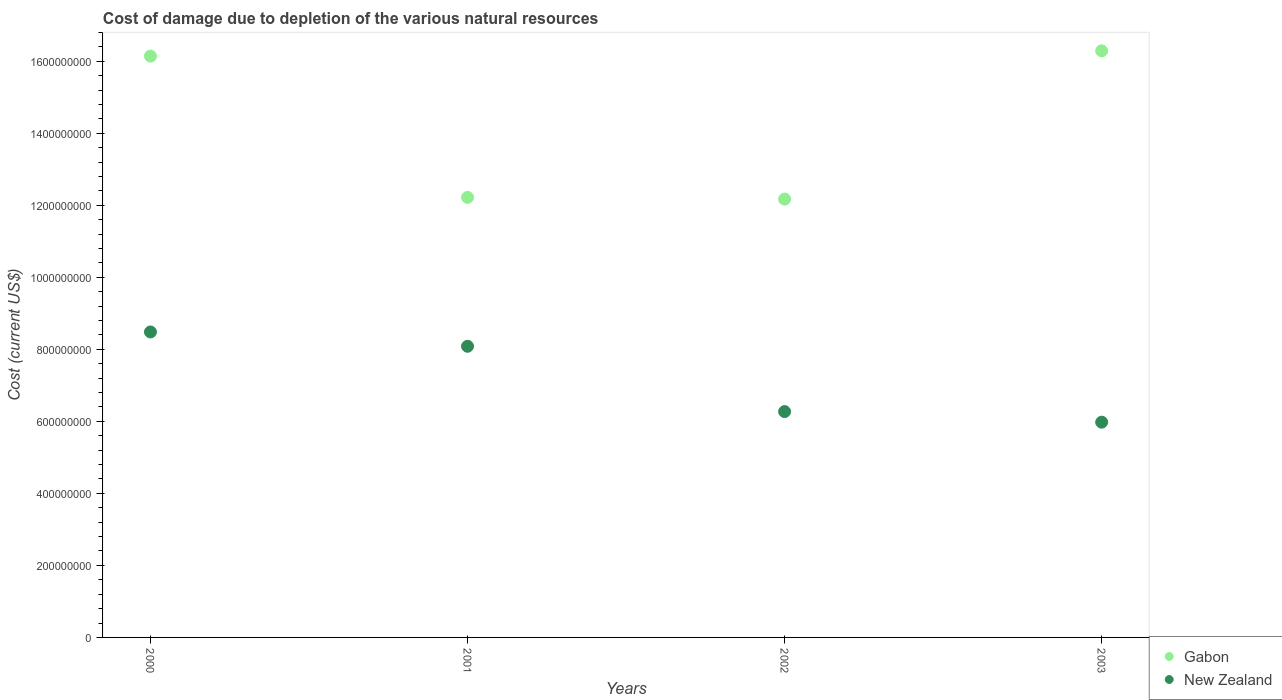What is the cost of damage caused due to the depletion of various natural resources in Gabon in 2002?
Your answer should be compact. 1.22e+09. Across all years, what is the maximum cost of damage caused due to the depletion of various natural resources in Gabon?
Provide a short and direct response. 1.63e+09. Across all years, what is the minimum cost of damage caused due to the depletion of various natural resources in New Zealand?
Provide a succinct answer. 5.98e+08. In which year was the cost of damage caused due to the depletion of various natural resources in Gabon maximum?
Offer a very short reply. 2003. What is the total cost of damage caused due to the depletion of various natural resources in Gabon in the graph?
Ensure brevity in your answer.  5.68e+09. What is the difference between the cost of damage caused due to the depletion of various natural resources in New Zealand in 2000 and that in 2001?
Offer a very short reply. 3.98e+07. What is the difference between the cost of damage caused due to the depletion of various natural resources in New Zealand in 2002 and the cost of damage caused due to the depletion of various natural resources in Gabon in 2000?
Offer a terse response. -9.87e+08. What is the average cost of damage caused due to the depletion of various natural resources in New Zealand per year?
Your answer should be very brief. 7.20e+08. In the year 2000, what is the difference between the cost of damage caused due to the depletion of various natural resources in New Zealand and cost of damage caused due to the depletion of various natural resources in Gabon?
Your response must be concise. -7.66e+08. In how many years, is the cost of damage caused due to the depletion of various natural resources in Gabon greater than 400000000 US$?
Your response must be concise. 4. What is the ratio of the cost of damage caused due to the depletion of various natural resources in New Zealand in 2000 to that in 2003?
Your response must be concise. 1.42. Is the cost of damage caused due to the depletion of various natural resources in New Zealand in 2001 less than that in 2002?
Offer a very short reply. No. Is the difference between the cost of damage caused due to the depletion of various natural resources in New Zealand in 2001 and 2003 greater than the difference between the cost of damage caused due to the depletion of various natural resources in Gabon in 2001 and 2003?
Offer a very short reply. Yes. What is the difference between the highest and the second highest cost of damage caused due to the depletion of various natural resources in Gabon?
Provide a short and direct response. 1.47e+07. What is the difference between the highest and the lowest cost of damage caused due to the depletion of various natural resources in Gabon?
Keep it short and to the point. 4.12e+08. Are the values on the major ticks of Y-axis written in scientific E-notation?
Make the answer very short. No. How many legend labels are there?
Your answer should be very brief. 2. What is the title of the graph?
Give a very brief answer. Cost of damage due to depletion of the various natural resources. Does "Angola" appear as one of the legend labels in the graph?
Offer a terse response. No. What is the label or title of the Y-axis?
Keep it short and to the point. Cost (current US$). What is the Cost (current US$) in Gabon in 2000?
Make the answer very short. 1.61e+09. What is the Cost (current US$) in New Zealand in 2000?
Your answer should be very brief. 8.48e+08. What is the Cost (current US$) in Gabon in 2001?
Provide a short and direct response. 1.22e+09. What is the Cost (current US$) of New Zealand in 2001?
Ensure brevity in your answer.  8.08e+08. What is the Cost (current US$) in Gabon in 2002?
Your response must be concise. 1.22e+09. What is the Cost (current US$) of New Zealand in 2002?
Ensure brevity in your answer.  6.27e+08. What is the Cost (current US$) in Gabon in 2003?
Your answer should be compact. 1.63e+09. What is the Cost (current US$) of New Zealand in 2003?
Keep it short and to the point. 5.98e+08. Across all years, what is the maximum Cost (current US$) in Gabon?
Your answer should be very brief. 1.63e+09. Across all years, what is the maximum Cost (current US$) in New Zealand?
Your answer should be very brief. 8.48e+08. Across all years, what is the minimum Cost (current US$) of Gabon?
Provide a succinct answer. 1.22e+09. Across all years, what is the minimum Cost (current US$) in New Zealand?
Offer a very short reply. 5.98e+08. What is the total Cost (current US$) of Gabon in the graph?
Keep it short and to the point. 5.68e+09. What is the total Cost (current US$) of New Zealand in the graph?
Keep it short and to the point. 2.88e+09. What is the difference between the Cost (current US$) in Gabon in 2000 and that in 2001?
Give a very brief answer. 3.92e+08. What is the difference between the Cost (current US$) in New Zealand in 2000 and that in 2001?
Provide a short and direct response. 3.98e+07. What is the difference between the Cost (current US$) of Gabon in 2000 and that in 2002?
Give a very brief answer. 3.97e+08. What is the difference between the Cost (current US$) of New Zealand in 2000 and that in 2002?
Your answer should be very brief. 2.21e+08. What is the difference between the Cost (current US$) of Gabon in 2000 and that in 2003?
Your response must be concise. -1.47e+07. What is the difference between the Cost (current US$) of New Zealand in 2000 and that in 2003?
Ensure brevity in your answer.  2.51e+08. What is the difference between the Cost (current US$) in Gabon in 2001 and that in 2002?
Your answer should be very brief. 4.75e+06. What is the difference between the Cost (current US$) in New Zealand in 2001 and that in 2002?
Ensure brevity in your answer.  1.81e+08. What is the difference between the Cost (current US$) in Gabon in 2001 and that in 2003?
Offer a very short reply. -4.07e+08. What is the difference between the Cost (current US$) in New Zealand in 2001 and that in 2003?
Ensure brevity in your answer.  2.11e+08. What is the difference between the Cost (current US$) of Gabon in 2002 and that in 2003?
Your response must be concise. -4.12e+08. What is the difference between the Cost (current US$) in New Zealand in 2002 and that in 2003?
Make the answer very short. 2.94e+07. What is the difference between the Cost (current US$) in Gabon in 2000 and the Cost (current US$) in New Zealand in 2001?
Ensure brevity in your answer.  8.06e+08. What is the difference between the Cost (current US$) in Gabon in 2000 and the Cost (current US$) in New Zealand in 2002?
Keep it short and to the point. 9.87e+08. What is the difference between the Cost (current US$) in Gabon in 2000 and the Cost (current US$) in New Zealand in 2003?
Your answer should be compact. 1.02e+09. What is the difference between the Cost (current US$) of Gabon in 2001 and the Cost (current US$) of New Zealand in 2002?
Provide a short and direct response. 5.95e+08. What is the difference between the Cost (current US$) in Gabon in 2001 and the Cost (current US$) in New Zealand in 2003?
Give a very brief answer. 6.24e+08. What is the difference between the Cost (current US$) of Gabon in 2002 and the Cost (current US$) of New Zealand in 2003?
Provide a short and direct response. 6.19e+08. What is the average Cost (current US$) of Gabon per year?
Provide a succinct answer. 1.42e+09. What is the average Cost (current US$) in New Zealand per year?
Your answer should be very brief. 7.20e+08. In the year 2000, what is the difference between the Cost (current US$) in Gabon and Cost (current US$) in New Zealand?
Ensure brevity in your answer.  7.66e+08. In the year 2001, what is the difference between the Cost (current US$) in Gabon and Cost (current US$) in New Zealand?
Your answer should be very brief. 4.13e+08. In the year 2002, what is the difference between the Cost (current US$) in Gabon and Cost (current US$) in New Zealand?
Provide a short and direct response. 5.90e+08. In the year 2003, what is the difference between the Cost (current US$) of Gabon and Cost (current US$) of New Zealand?
Your answer should be compact. 1.03e+09. What is the ratio of the Cost (current US$) of Gabon in 2000 to that in 2001?
Provide a short and direct response. 1.32. What is the ratio of the Cost (current US$) in New Zealand in 2000 to that in 2001?
Give a very brief answer. 1.05. What is the ratio of the Cost (current US$) in Gabon in 2000 to that in 2002?
Ensure brevity in your answer.  1.33. What is the ratio of the Cost (current US$) of New Zealand in 2000 to that in 2002?
Ensure brevity in your answer.  1.35. What is the ratio of the Cost (current US$) in Gabon in 2000 to that in 2003?
Your answer should be very brief. 0.99. What is the ratio of the Cost (current US$) in New Zealand in 2000 to that in 2003?
Give a very brief answer. 1.42. What is the ratio of the Cost (current US$) of Gabon in 2001 to that in 2002?
Your answer should be compact. 1. What is the ratio of the Cost (current US$) of New Zealand in 2001 to that in 2002?
Ensure brevity in your answer.  1.29. What is the ratio of the Cost (current US$) of Gabon in 2001 to that in 2003?
Your answer should be compact. 0.75. What is the ratio of the Cost (current US$) of New Zealand in 2001 to that in 2003?
Your answer should be compact. 1.35. What is the ratio of the Cost (current US$) in Gabon in 2002 to that in 2003?
Keep it short and to the point. 0.75. What is the ratio of the Cost (current US$) of New Zealand in 2002 to that in 2003?
Give a very brief answer. 1.05. What is the difference between the highest and the second highest Cost (current US$) of Gabon?
Make the answer very short. 1.47e+07. What is the difference between the highest and the second highest Cost (current US$) in New Zealand?
Make the answer very short. 3.98e+07. What is the difference between the highest and the lowest Cost (current US$) of Gabon?
Ensure brevity in your answer.  4.12e+08. What is the difference between the highest and the lowest Cost (current US$) of New Zealand?
Offer a terse response. 2.51e+08. 